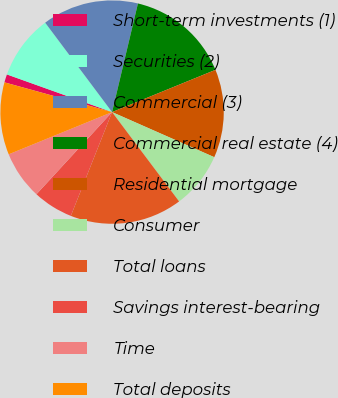Convert chart to OTSL. <chart><loc_0><loc_0><loc_500><loc_500><pie_chart><fcel>Short-term investments (1)<fcel>Securities (2)<fcel>Commercial (3)<fcel>Commercial real estate (4)<fcel>Residential mortgage<fcel>Consumer<fcel>Total loans<fcel>Savings interest-bearing<fcel>Time<fcel>Total deposits<nl><fcel>1.18%<fcel>9.3%<fcel>13.94%<fcel>15.1%<fcel>12.78%<fcel>8.14%<fcel>16.26%<fcel>5.82%<fcel>6.98%<fcel>10.46%<nl></chart> 